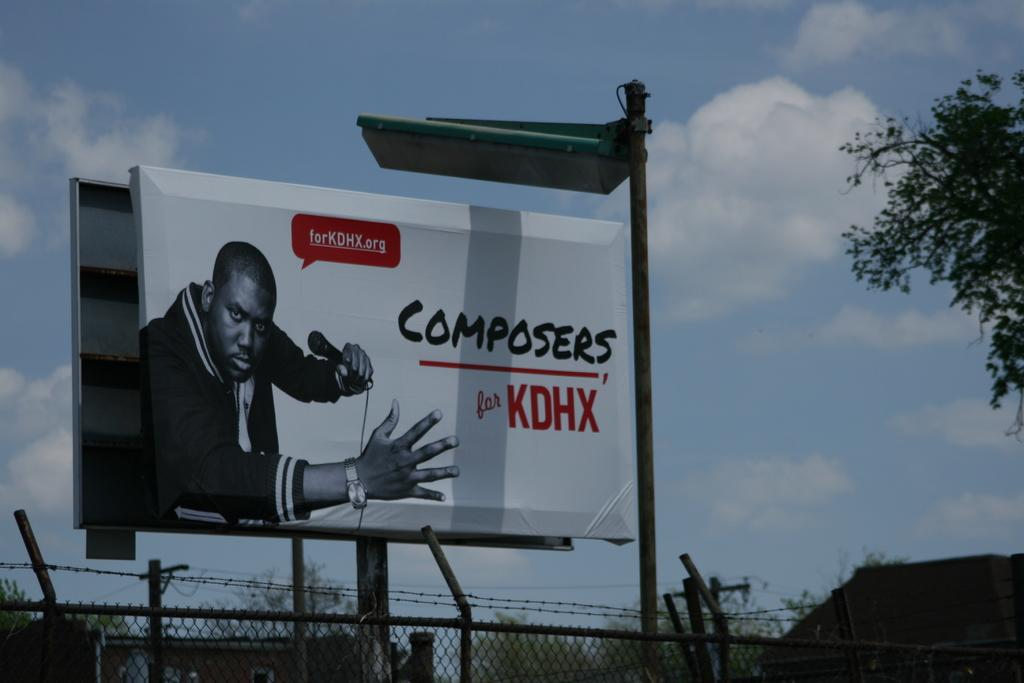<image>
Write a terse but informative summary of the picture. A billboard above a fence advertising Composers for KDHX 